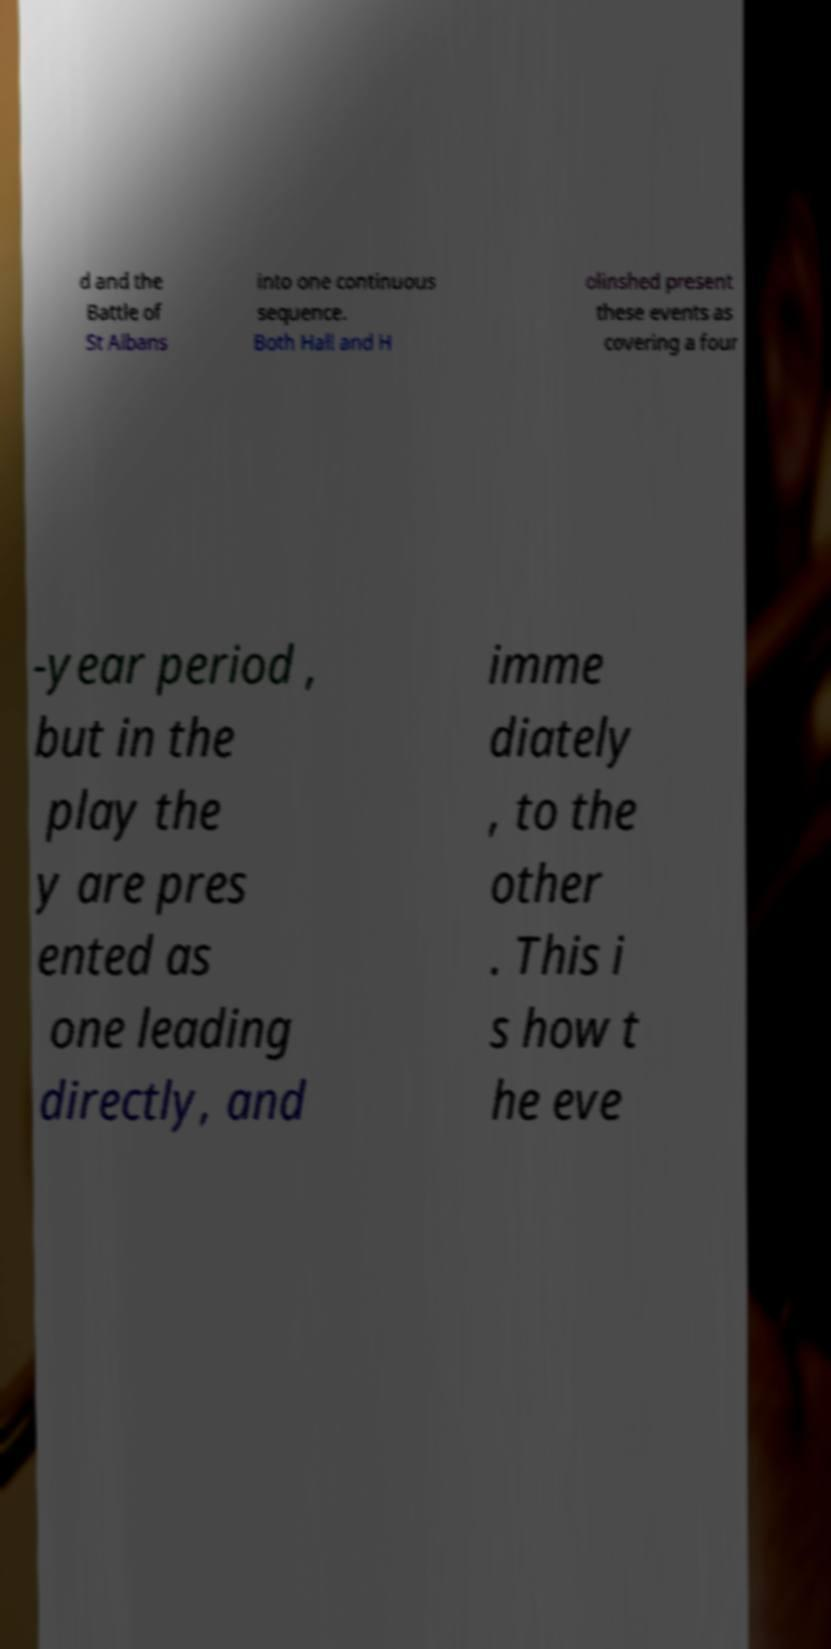I need the written content from this picture converted into text. Can you do that? d and the Battle of St Albans into one continuous sequence. Both Hall and H olinshed present these events as covering a four -year period , but in the play the y are pres ented as one leading directly, and imme diately , to the other . This i s how t he eve 